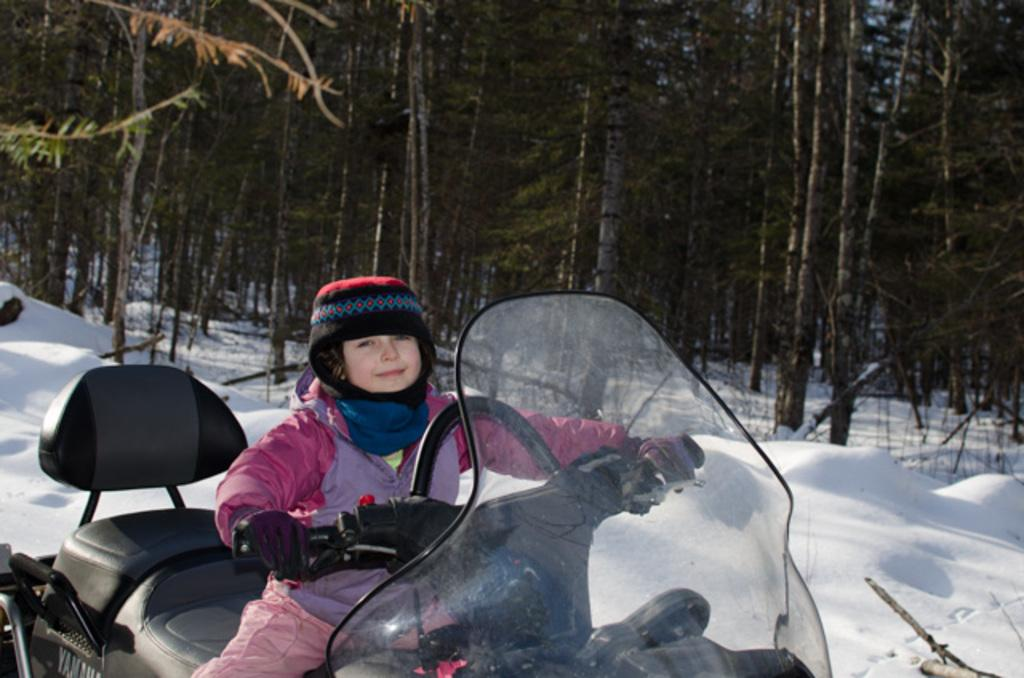Who is the main subject in the image? There is a girl in the image. What is the girl doing in the image? The girl is sitting on a vehicle. What is the girl wearing on her head? The girl is wearing a cap. What is the weather like in the image? There is snow visible in the image. What can be seen in the background of the image? There are trees in the background of the image. Can you tell me how many sheep are present on the farm in the image? There is no farm or sheep present in the image; it features a girl sitting on a vehicle with snow and trees in the background. 